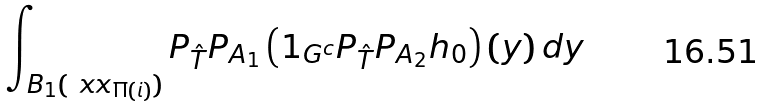Convert formula to latex. <formula><loc_0><loc_0><loc_500><loc_500>\int _ { B _ { 1 } ( \ x x _ { \Pi ( \i i ) } ) } P _ { \hat { T } } P _ { A _ { 1 } } \left ( 1 _ { G ^ { c } } P _ { \hat { T } } P _ { A _ { 2 } } h _ { 0 } \right ) ( y ) \, d y</formula> 